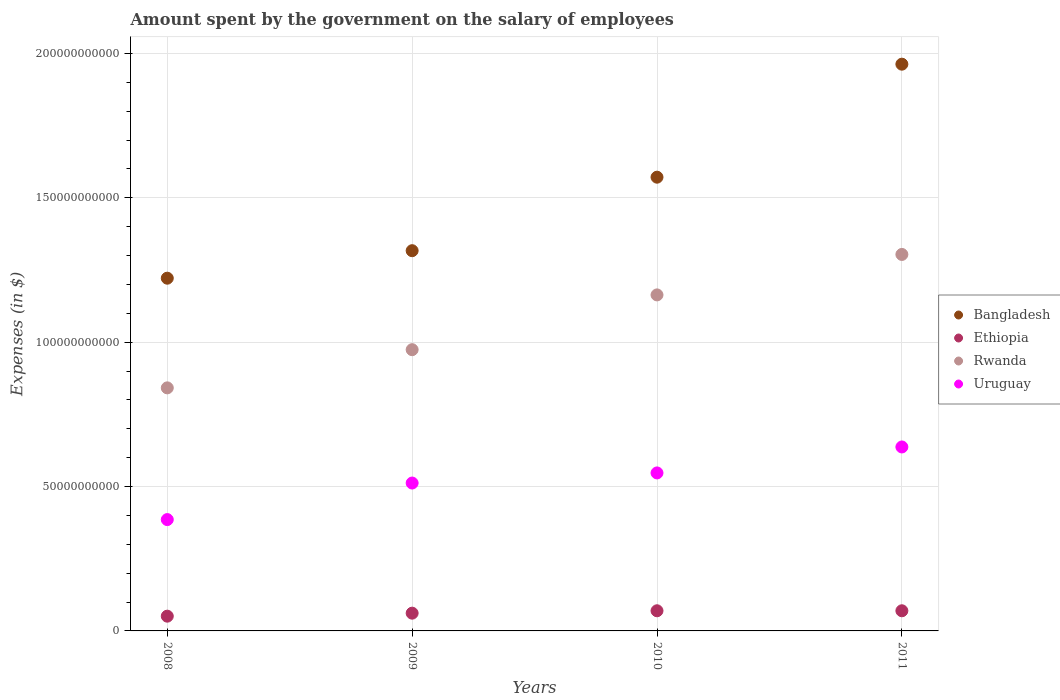How many different coloured dotlines are there?
Your answer should be very brief. 4. What is the amount spent on the salary of employees by the government in Uruguay in 2010?
Your answer should be very brief. 5.47e+1. Across all years, what is the maximum amount spent on the salary of employees by the government in Rwanda?
Your answer should be very brief. 1.30e+11. Across all years, what is the minimum amount spent on the salary of employees by the government in Uruguay?
Offer a very short reply. 3.86e+1. In which year was the amount spent on the salary of employees by the government in Uruguay maximum?
Offer a very short reply. 2011. In which year was the amount spent on the salary of employees by the government in Bangladesh minimum?
Provide a succinct answer. 2008. What is the total amount spent on the salary of employees by the government in Uruguay in the graph?
Provide a succinct answer. 2.08e+11. What is the difference between the amount spent on the salary of employees by the government in Rwanda in 2008 and that in 2010?
Provide a short and direct response. -3.22e+1. What is the difference between the amount spent on the salary of employees by the government in Rwanda in 2010 and the amount spent on the salary of employees by the government in Uruguay in 2009?
Offer a terse response. 6.52e+1. What is the average amount spent on the salary of employees by the government in Ethiopia per year?
Your answer should be compact. 6.30e+09. In the year 2008, what is the difference between the amount spent on the salary of employees by the government in Bangladesh and amount spent on the salary of employees by the government in Ethiopia?
Provide a short and direct response. 1.17e+11. In how many years, is the amount spent on the salary of employees by the government in Ethiopia greater than 100000000000 $?
Give a very brief answer. 0. What is the ratio of the amount spent on the salary of employees by the government in Ethiopia in 2009 to that in 2011?
Offer a terse response. 0.88. What is the difference between the highest and the lowest amount spent on the salary of employees by the government in Rwanda?
Ensure brevity in your answer.  4.62e+1. Does the amount spent on the salary of employees by the government in Rwanda monotonically increase over the years?
Make the answer very short. Yes. Is the amount spent on the salary of employees by the government in Bangladesh strictly greater than the amount spent on the salary of employees by the government in Uruguay over the years?
Offer a very short reply. Yes. How many years are there in the graph?
Provide a succinct answer. 4. What is the difference between two consecutive major ticks on the Y-axis?
Make the answer very short. 5.00e+1. Are the values on the major ticks of Y-axis written in scientific E-notation?
Your answer should be very brief. No. What is the title of the graph?
Offer a very short reply. Amount spent by the government on the salary of employees. What is the label or title of the Y-axis?
Your response must be concise. Expenses (in $). What is the Expenses (in $) of Bangladesh in 2008?
Provide a short and direct response. 1.22e+11. What is the Expenses (in $) of Ethiopia in 2008?
Give a very brief answer. 5.11e+09. What is the Expenses (in $) of Rwanda in 2008?
Ensure brevity in your answer.  8.42e+1. What is the Expenses (in $) of Uruguay in 2008?
Offer a very short reply. 3.86e+1. What is the Expenses (in $) of Bangladesh in 2009?
Offer a very short reply. 1.32e+11. What is the Expenses (in $) of Ethiopia in 2009?
Give a very brief answer. 6.15e+09. What is the Expenses (in $) of Rwanda in 2009?
Offer a terse response. 9.74e+1. What is the Expenses (in $) of Uruguay in 2009?
Keep it short and to the point. 5.12e+1. What is the Expenses (in $) in Bangladesh in 2010?
Offer a terse response. 1.57e+11. What is the Expenses (in $) in Ethiopia in 2010?
Give a very brief answer. 6.98e+09. What is the Expenses (in $) of Rwanda in 2010?
Provide a succinct answer. 1.16e+11. What is the Expenses (in $) of Uruguay in 2010?
Offer a very short reply. 5.47e+1. What is the Expenses (in $) of Bangladesh in 2011?
Give a very brief answer. 1.96e+11. What is the Expenses (in $) in Ethiopia in 2011?
Ensure brevity in your answer.  6.98e+09. What is the Expenses (in $) of Rwanda in 2011?
Provide a short and direct response. 1.30e+11. What is the Expenses (in $) of Uruguay in 2011?
Give a very brief answer. 6.37e+1. Across all years, what is the maximum Expenses (in $) of Bangladesh?
Ensure brevity in your answer.  1.96e+11. Across all years, what is the maximum Expenses (in $) of Ethiopia?
Provide a succinct answer. 6.98e+09. Across all years, what is the maximum Expenses (in $) in Rwanda?
Your answer should be compact. 1.30e+11. Across all years, what is the maximum Expenses (in $) in Uruguay?
Provide a succinct answer. 6.37e+1. Across all years, what is the minimum Expenses (in $) of Bangladesh?
Offer a very short reply. 1.22e+11. Across all years, what is the minimum Expenses (in $) in Ethiopia?
Your answer should be very brief. 5.11e+09. Across all years, what is the minimum Expenses (in $) in Rwanda?
Keep it short and to the point. 8.42e+1. Across all years, what is the minimum Expenses (in $) in Uruguay?
Offer a very short reply. 3.86e+1. What is the total Expenses (in $) in Bangladesh in the graph?
Your answer should be very brief. 6.07e+11. What is the total Expenses (in $) of Ethiopia in the graph?
Offer a very short reply. 2.52e+1. What is the total Expenses (in $) of Rwanda in the graph?
Provide a short and direct response. 4.28e+11. What is the total Expenses (in $) of Uruguay in the graph?
Give a very brief answer. 2.08e+11. What is the difference between the Expenses (in $) of Bangladesh in 2008 and that in 2009?
Offer a terse response. -9.53e+09. What is the difference between the Expenses (in $) in Ethiopia in 2008 and that in 2009?
Provide a succinct answer. -1.04e+09. What is the difference between the Expenses (in $) of Rwanda in 2008 and that in 2009?
Keep it short and to the point. -1.32e+1. What is the difference between the Expenses (in $) of Uruguay in 2008 and that in 2009?
Provide a short and direct response. -1.27e+1. What is the difference between the Expenses (in $) in Bangladesh in 2008 and that in 2010?
Offer a terse response. -3.50e+1. What is the difference between the Expenses (in $) of Ethiopia in 2008 and that in 2010?
Offer a very short reply. -1.87e+09. What is the difference between the Expenses (in $) of Rwanda in 2008 and that in 2010?
Provide a short and direct response. -3.22e+1. What is the difference between the Expenses (in $) in Uruguay in 2008 and that in 2010?
Your answer should be very brief. -1.62e+1. What is the difference between the Expenses (in $) in Bangladesh in 2008 and that in 2011?
Make the answer very short. -7.41e+1. What is the difference between the Expenses (in $) of Ethiopia in 2008 and that in 2011?
Your answer should be compact. -1.87e+09. What is the difference between the Expenses (in $) in Rwanda in 2008 and that in 2011?
Give a very brief answer. -4.62e+1. What is the difference between the Expenses (in $) of Uruguay in 2008 and that in 2011?
Give a very brief answer. -2.51e+1. What is the difference between the Expenses (in $) of Bangladesh in 2009 and that in 2010?
Provide a short and direct response. -2.55e+1. What is the difference between the Expenses (in $) of Ethiopia in 2009 and that in 2010?
Ensure brevity in your answer.  -8.29e+08. What is the difference between the Expenses (in $) of Rwanda in 2009 and that in 2010?
Ensure brevity in your answer.  -1.90e+1. What is the difference between the Expenses (in $) of Uruguay in 2009 and that in 2010?
Your answer should be compact. -3.50e+09. What is the difference between the Expenses (in $) in Bangladesh in 2009 and that in 2011?
Make the answer very short. -6.46e+1. What is the difference between the Expenses (in $) in Ethiopia in 2009 and that in 2011?
Make the answer very short. -8.29e+08. What is the difference between the Expenses (in $) in Rwanda in 2009 and that in 2011?
Provide a succinct answer. -3.30e+1. What is the difference between the Expenses (in $) of Uruguay in 2009 and that in 2011?
Make the answer very short. -1.25e+1. What is the difference between the Expenses (in $) of Bangladesh in 2010 and that in 2011?
Your answer should be very brief. -3.91e+1. What is the difference between the Expenses (in $) in Rwanda in 2010 and that in 2011?
Your answer should be very brief. -1.40e+1. What is the difference between the Expenses (in $) of Uruguay in 2010 and that in 2011?
Keep it short and to the point. -8.99e+09. What is the difference between the Expenses (in $) of Bangladesh in 2008 and the Expenses (in $) of Ethiopia in 2009?
Provide a succinct answer. 1.16e+11. What is the difference between the Expenses (in $) in Bangladesh in 2008 and the Expenses (in $) in Rwanda in 2009?
Keep it short and to the point. 2.48e+1. What is the difference between the Expenses (in $) of Bangladesh in 2008 and the Expenses (in $) of Uruguay in 2009?
Ensure brevity in your answer.  7.09e+1. What is the difference between the Expenses (in $) in Ethiopia in 2008 and the Expenses (in $) in Rwanda in 2009?
Ensure brevity in your answer.  -9.23e+1. What is the difference between the Expenses (in $) in Ethiopia in 2008 and the Expenses (in $) in Uruguay in 2009?
Provide a succinct answer. -4.61e+1. What is the difference between the Expenses (in $) of Rwanda in 2008 and the Expenses (in $) of Uruguay in 2009?
Give a very brief answer. 3.30e+1. What is the difference between the Expenses (in $) in Bangladesh in 2008 and the Expenses (in $) in Ethiopia in 2010?
Keep it short and to the point. 1.15e+11. What is the difference between the Expenses (in $) in Bangladesh in 2008 and the Expenses (in $) in Rwanda in 2010?
Make the answer very short. 5.78e+09. What is the difference between the Expenses (in $) in Bangladesh in 2008 and the Expenses (in $) in Uruguay in 2010?
Give a very brief answer. 6.74e+1. What is the difference between the Expenses (in $) in Ethiopia in 2008 and the Expenses (in $) in Rwanda in 2010?
Keep it short and to the point. -1.11e+11. What is the difference between the Expenses (in $) in Ethiopia in 2008 and the Expenses (in $) in Uruguay in 2010?
Provide a succinct answer. -4.96e+1. What is the difference between the Expenses (in $) in Rwanda in 2008 and the Expenses (in $) in Uruguay in 2010?
Give a very brief answer. 2.95e+1. What is the difference between the Expenses (in $) of Bangladesh in 2008 and the Expenses (in $) of Ethiopia in 2011?
Keep it short and to the point. 1.15e+11. What is the difference between the Expenses (in $) in Bangladesh in 2008 and the Expenses (in $) in Rwanda in 2011?
Your answer should be compact. -8.23e+09. What is the difference between the Expenses (in $) of Bangladesh in 2008 and the Expenses (in $) of Uruguay in 2011?
Give a very brief answer. 5.84e+1. What is the difference between the Expenses (in $) in Ethiopia in 2008 and the Expenses (in $) in Rwanda in 2011?
Your response must be concise. -1.25e+11. What is the difference between the Expenses (in $) of Ethiopia in 2008 and the Expenses (in $) of Uruguay in 2011?
Provide a short and direct response. -5.86e+1. What is the difference between the Expenses (in $) in Rwanda in 2008 and the Expenses (in $) in Uruguay in 2011?
Make the answer very short. 2.05e+1. What is the difference between the Expenses (in $) of Bangladesh in 2009 and the Expenses (in $) of Ethiopia in 2010?
Your response must be concise. 1.25e+11. What is the difference between the Expenses (in $) of Bangladesh in 2009 and the Expenses (in $) of Rwanda in 2010?
Your response must be concise. 1.53e+1. What is the difference between the Expenses (in $) in Bangladesh in 2009 and the Expenses (in $) in Uruguay in 2010?
Ensure brevity in your answer.  7.70e+1. What is the difference between the Expenses (in $) of Ethiopia in 2009 and the Expenses (in $) of Rwanda in 2010?
Keep it short and to the point. -1.10e+11. What is the difference between the Expenses (in $) in Ethiopia in 2009 and the Expenses (in $) in Uruguay in 2010?
Your answer should be very brief. -4.86e+1. What is the difference between the Expenses (in $) of Rwanda in 2009 and the Expenses (in $) of Uruguay in 2010?
Ensure brevity in your answer.  4.27e+1. What is the difference between the Expenses (in $) in Bangladesh in 2009 and the Expenses (in $) in Ethiopia in 2011?
Give a very brief answer. 1.25e+11. What is the difference between the Expenses (in $) of Bangladesh in 2009 and the Expenses (in $) of Rwanda in 2011?
Ensure brevity in your answer.  1.30e+09. What is the difference between the Expenses (in $) of Bangladesh in 2009 and the Expenses (in $) of Uruguay in 2011?
Provide a succinct answer. 6.80e+1. What is the difference between the Expenses (in $) in Ethiopia in 2009 and the Expenses (in $) in Rwanda in 2011?
Give a very brief answer. -1.24e+11. What is the difference between the Expenses (in $) in Ethiopia in 2009 and the Expenses (in $) in Uruguay in 2011?
Your answer should be very brief. -5.76e+1. What is the difference between the Expenses (in $) of Rwanda in 2009 and the Expenses (in $) of Uruguay in 2011?
Your response must be concise. 3.37e+1. What is the difference between the Expenses (in $) of Bangladesh in 2010 and the Expenses (in $) of Ethiopia in 2011?
Give a very brief answer. 1.50e+11. What is the difference between the Expenses (in $) of Bangladesh in 2010 and the Expenses (in $) of Rwanda in 2011?
Provide a short and direct response. 2.68e+1. What is the difference between the Expenses (in $) in Bangladesh in 2010 and the Expenses (in $) in Uruguay in 2011?
Make the answer very short. 9.34e+1. What is the difference between the Expenses (in $) of Ethiopia in 2010 and the Expenses (in $) of Rwanda in 2011?
Make the answer very short. -1.23e+11. What is the difference between the Expenses (in $) in Ethiopia in 2010 and the Expenses (in $) in Uruguay in 2011?
Your response must be concise. -5.67e+1. What is the difference between the Expenses (in $) of Rwanda in 2010 and the Expenses (in $) of Uruguay in 2011?
Give a very brief answer. 5.27e+1. What is the average Expenses (in $) of Bangladesh per year?
Make the answer very short. 1.52e+11. What is the average Expenses (in $) in Ethiopia per year?
Provide a short and direct response. 6.30e+09. What is the average Expenses (in $) of Rwanda per year?
Offer a very short reply. 1.07e+11. What is the average Expenses (in $) of Uruguay per year?
Offer a very short reply. 5.21e+1. In the year 2008, what is the difference between the Expenses (in $) in Bangladesh and Expenses (in $) in Ethiopia?
Your response must be concise. 1.17e+11. In the year 2008, what is the difference between the Expenses (in $) in Bangladesh and Expenses (in $) in Rwanda?
Provide a succinct answer. 3.80e+1. In the year 2008, what is the difference between the Expenses (in $) of Bangladesh and Expenses (in $) of Uruguay?
Your answer should be very brief. 8.36e+1. In the year 2008, what is the difference between the Expenses (in $) in Ethiopia and Expenses (in $) in Rwanda?
Ensure brevity in your answer.  -7.91e+1. In the year 2008, what is the difference between the Expenses (in $) in Ethiopia and Expenses (in $) in Uruguay?
Ensure brevity in your answer.  -3.35e+1. In the year 2008, what is the difference between the Expenses (in $) of Rwanda and Expenses (in $) of Uruguay?
Offer a very short reply. 4.56e+1. In the year 2009, what is the difference between the Expenses (in $) in Bangladesh and Expenses (in $) in Ethiopia?
Provide a short and direct response. 1.26e+11. In the year 2009, what is the difference between the Expenses (in $) in Bangladesh and Expenses (in $) in Rwanda?
Provide a short and direct response. 3.43e+1. In the year 2009, what is the difference between the Expenses (in $) in Bangladesh and Expenses (in $) in Uruguay?
Your answer should be very brief. 8.05e+1. In the year 2009, what is the difference between the Expenses (in $) in Ethiopia and Expenses (in $) in Rwanda?
Make the answer very short. -9.13e+1. In the year 2009, what is the difference between the Expenses (in $) in Ethiopia and Expenses (in $) in Uruguay?
Ensure brevity in your answer.  -4.51e+1. In the year 2009, what is the difference between the Expenses (in $) of Rwanda and Expenses (in $) of Uruguay?
Ensure brevity in your answer.  4.62e+1. In the year 2010, what is the difference between the Expenses (in $) in Bangladesh and Expenses (in $) in Ethiopia?
Your answer should be very brief. 1.50e+11. In the year 2010, what is the difference between the Expenses (in $) of Bangladesh and Expenses (in $) of Rwanda?
Ensure brevity in your answer.  4.08e+1. In the year 2010, what is the difference between the Expenses (in $) in Bangladesh and Expenses (in $) in Uruguay?
Offer a very short reply. 1.02e+11. In the year 2010, what is the difference between the Expenses (in $) of Ethiopia and Expenses (in $) of Rwanda?
Provide a short and direct response. -1.09e+11. In the year 2010, what is the difference between the Expenses (in $) in Ethiopia and Expenses (in $) in Uruguay?
Ensure brevity in your answer.  -4.77e+1. In the year 2010, what is the difference between the Expenses (in $) of Rwanda and Expenses (in $) of Uruguay?
Offer a very short reply. 6.17e+1. In the year 2011, what is the difference between the Expenses (in $) in Bangladesh and Expenses (in $) in Ethiopia?
Provide a succinct answer. 1.89e+11. In the year 2011, what is the difference between the Expenses (in $) in Bangladesh and Expenses (in $) in Rwanda?
Offer a terse response. 6.59e+1. In the year 2011, what is the difference between the Expenses (in $) of Bangladesh and Expenses (in $) of Uruguay?
Provide a succinct answer. 1.33e+11. In the year 2011, what is the difference between the Expenses (in $) of Ethiopia and Expenses (in $) of Rwanda?
Your answer should be very brief. -1.23e+11. In the year 2011, what is the difference between the Expenses (in $) of Ethiopia and Expenses (in $) of Uruguay?
Give a very brief answer. -5.67e+1. In the year 2011, what is the difference between the Expenses (in $) of Rwanda and Expenses (in $) of Uruguay?
Provide a short and direct response. 6.67e+1. What is the ratio of the Expenses (in $) in Bangladesh in 2008 to that in 2009?
Offer a very short reply. 0.93. What is the ratio of the Expenses (in $) of Ethiopia in 2008 to that in 2009?
Provide a succinct answer. 0.83. What is the ratio of the Expenses (in $) of Rwanda in 2008 to that in 2009?
Ensure brevity in your answer.  0.86. What is the ratio of the Expenses (in $) in Uruguay in 2008 to that in 2009?
Provide a succinct answer. 0.75. What is the ratio of the Expenses (in $) of Bangladesh in 2008 to that in 2010?
Your answer should be very brief. 0.78. What is the ratio of the Expenses (in $) of Ethiopia in 2008 to that in 2010?
Give a very brief answer. 0.73. What is the ratio of the Expenses (in $) in Rwanda in 2008 to that in 2010?
Provide a short and direct response. 0.72. What is the ratio of the Expenses (in $) of Uruguay in 2008 to that in 2010?
Your answer should be very brief. 0.7. What is the ratio of the Expenses (in $) in Bangladesh in 2008 to that in 2011?
Keep it short and to the point. 0.62. What is the ratio of the Expenses (in $) of Ethiopia in 2008 to that in 2011?
Provide a succinct answer. 0.73. What is the ratio of the Expenses (in $) in Rwanda in 2008 to that in 2011?
Make the answer very short. 0.65. What is the ratio of the Expenses (in $) of Uruguay in 2008 to that in 2011?
Keep it short and to the point. 0.61. What is the ratio of the Expenses (in $) of Bangladesh in 2009 to that in 2010?
Your response must be concise. 0.84. What is the ratio of the Expenses (in $) in Ethiopia in 2009 to that in 2010?
Offer a very short reply. 0.88. What is the ratio of the Expenses (in $) of Rwanda in 2009 to that in 2010?
Provide a short and direct response. 0.84. What is the ratio of the Expenses (in $) of Uruguay in 2009 to that in 2010?
Offer a very short reply. 0.94. What is the ratio of the Expenses (in $) of Bangladesh in 2009 to that in 2011?
Make the answer very short. 0.67. What is the ratio of the Expenses (in $) in Ethiopia in 2009 to that in 2011?
Your response must be concise. 0.88. What is the ratio of the Expenses (in $) of Rwanda in 2009 to that in 2011?
Provide a short and direct response. 0.75. What is the ratio of the Expenses (in $) in Uruguay in 2009 to that in 2011?
Keep it short and to the point. 0.8. What is the ratio of the Expenses (in $) in Bangladesh in 2010 to that in 2011?
Offer a very short reply. 0.8. What is the ratio of the Expenses (in $) in Rwanda in 2010 to that in 2011?
Your response must be concise. 0.89. What is the ratio of the Expenses (in $) of Uruguay in 2010 to that in 2011?
Provide a short and direct response. 0.86. What is the difference between the highest and the second highest Expenses (in $) of Bangladesh?
Provide a succinct answer. 3.91e+1. What is the difference between the highest and the second highest Expenses (in $) of Rwanda?
Give a very brief answer. 1.40e+1. What is the difference between the highest and the second highest Expenses (in $) in Uruguay?
Provide a short and direct response. 8.99e+09. What is the difference between the highest and the lowest Expenses (in $) of Bangladesh?
Keep it short and to the point. 7.41e+1. What is the difference between the highest and the lowest Expenses (in $) of Ethiopia?
Keep it short and to the point. 1.87e+09. What is the difference between the highest and the lowest Expenses (in $) of Rwanda?
Offer a terse response. 4.62e+1. What is the difference between the highest and the lowest Expenses (in $) of Uruguay?
Offer a very short reply. 2.51e+1. 